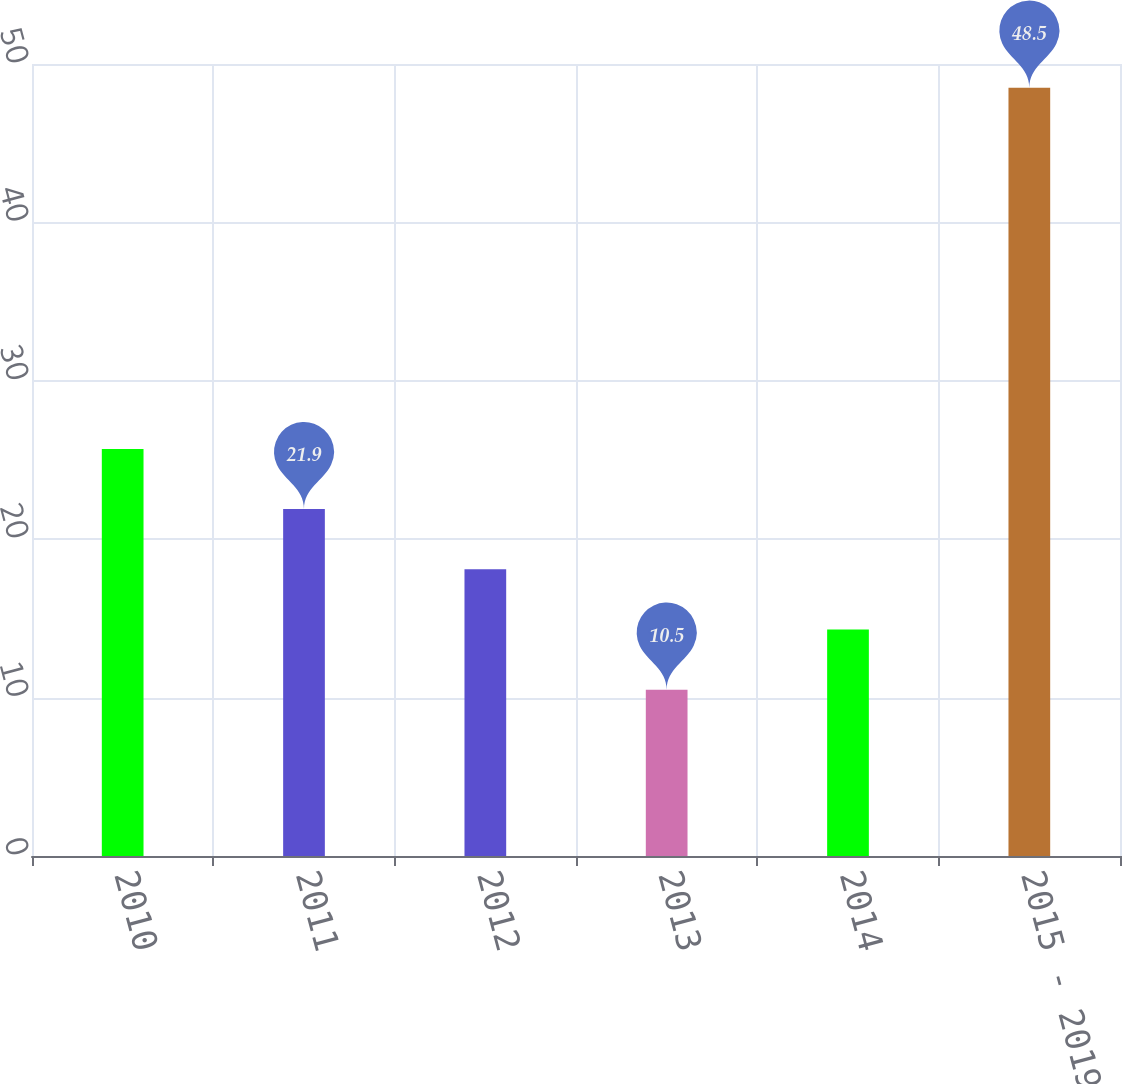Convert chart. <chart><loc_0><loc_0><loc_500><loc_500><bar_chart><fcel>2010<fcel>2011<fcel>2012<fcel>2013<fcel>2014<fcel>2015 - 2019<nl><fcel>25.7<fcel>21.9<fcel>18.1<fcel>10.5<fcel>14.3<fcel>48.5<nl></chart> 